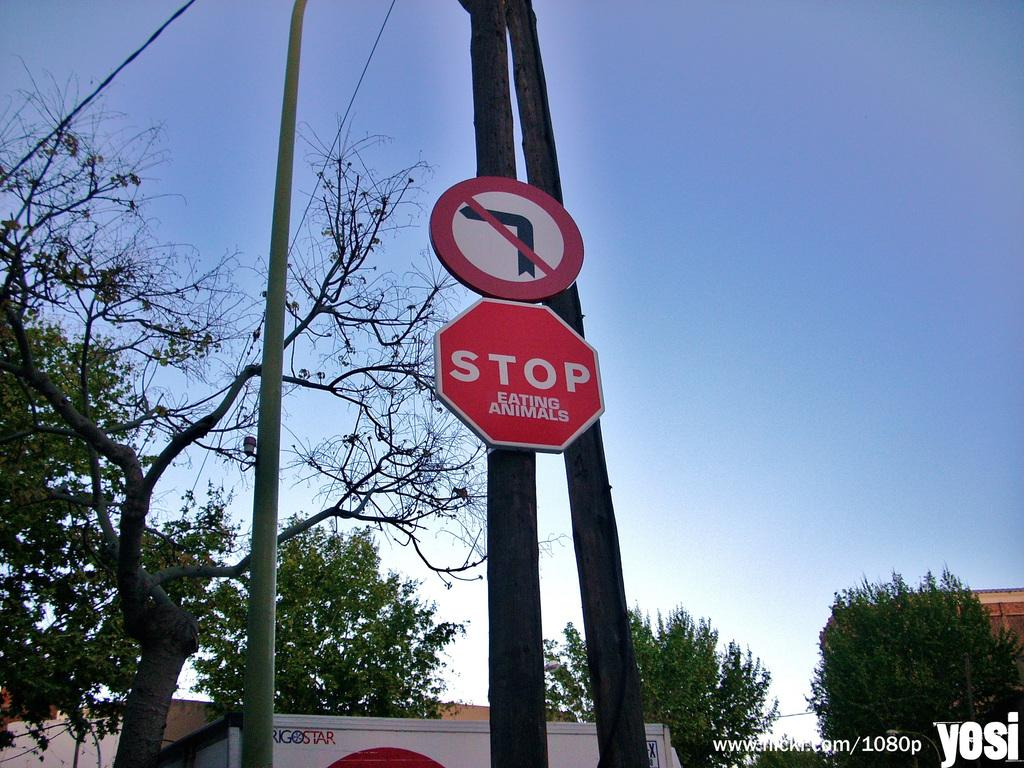<image>
Offer a succinct explanation of the picture presented. A red sign on a telephone pole says Stop Eating Animals. 